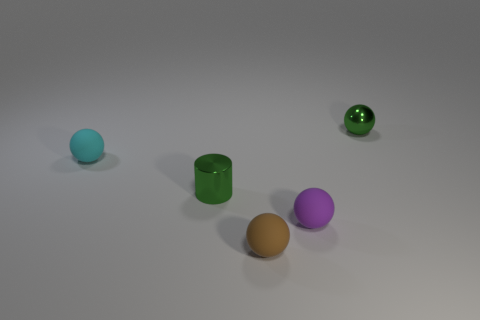Subtract all purple balls. How many balls are left? 3 Add 2 green metal spheres. How many objects exist? 7 Subtract all purple spheres. How many spheres are left? 3 Subtract all balls. How many objects are left? 1 Subtract 1 cylinders. How many cylinders are left? 0 Subtract all tiny red spheres. Subtract all green shiny cylinders. How many objects are left? 4 Add 1 small rubber balls. How many small rubber balls are left? 4 Add 4 brown objects. How many brown objects exist? 5 Subtract 0 brown blocks. How many objects are left? 5 Subtract all red cylinders. Subtract all yellow blocks. How many cylinders are left? 1 